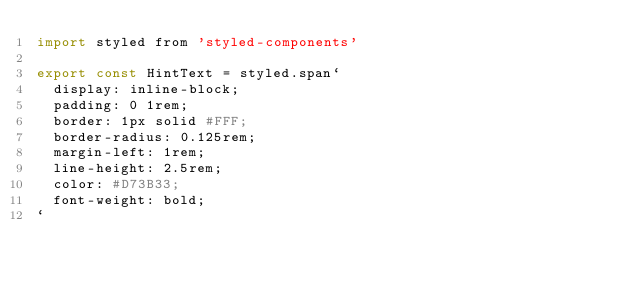Convert code to text. <code><loc_0><loc_0><loc_500><loc_500><_JavaScript_>import styled from 'styled-components'

export const HintText = styled.span`
  display: inline-block;
  padding: 0 1rem;
  border: 1px solid #FFF;
  border-radius: 0.125rem;
  margin-left: 1rem;
  line-height: 2.5rem;
  color: #D73B33;
  font-weight: bold;
`
</code> 